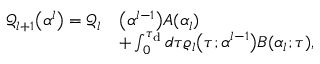<formula> <loc_0><loc_0><loc_500><loc_500>\begin{array} { r l } { \mathcal { Q } _ { l + 1 } \left ( \alpha ^ { l } \right ) = \mathcal { Q } _ { l } } & { \left ( \alpha ^ { l - 1 } \right ) A ( \alpha _ { l } ) } \\ & { + \int _ { 0 } ^ { \tau _ { d } } d \tau \varrho _ { l } \left ( \tau ; \alpha ^ { l - 1 } \right ) B ( \alpha _ { l } ; \tau ) , } \end{array}</formula> 